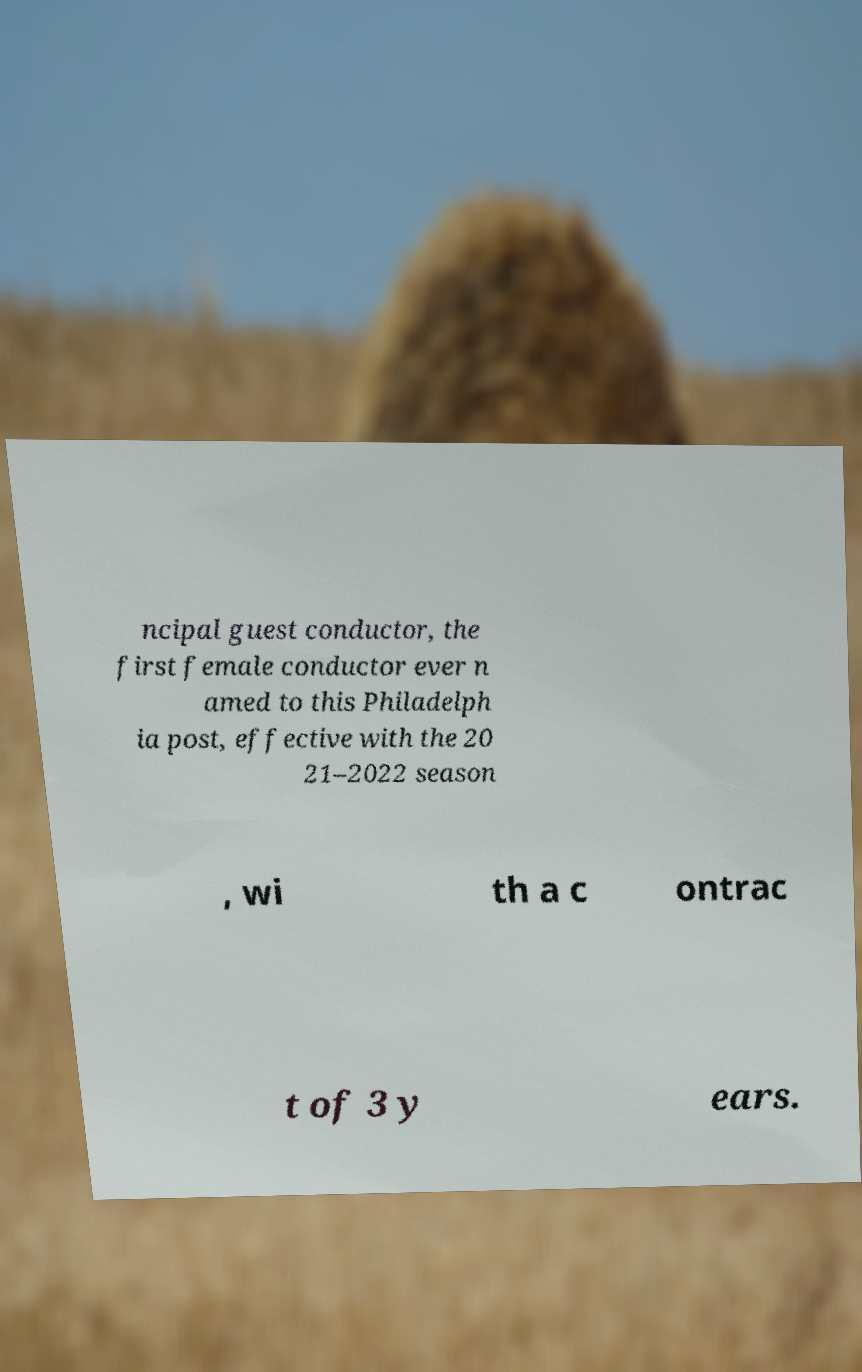For documentation purposes, I need the text within this image transcribed. Could you provide that? ncipal guest conductor, the first female conductor ever n amed to this Philadelph ia post, effective with the 20 21–2022 season , wi th a c ontrac t of 3 y ears. 